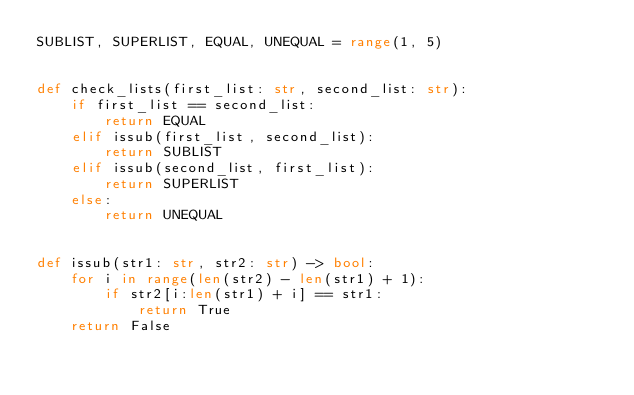<code> <loc_0><loc_0><loc_500><loc_500><_Python_>SUBLIST, SUPERLIST, EQUAL, UNEQUAL = range(1, 5)


def check_lists(first_list: str, second_list: str):
    if first_list == second_list:
        return EQUAL
    elif issub(first_list, second_list):
        return SUBLIST
    elif issub(second_list, first_list):
        return SUPERLIST
    else:
        return UNEQUAL


def issub(str1: str, str2: str) -> bool:
    for i in range(len(str2) - len(str1) + 1):
        if str2[i:len(str1) + i] == str1:
            return True
    return False
</code> 